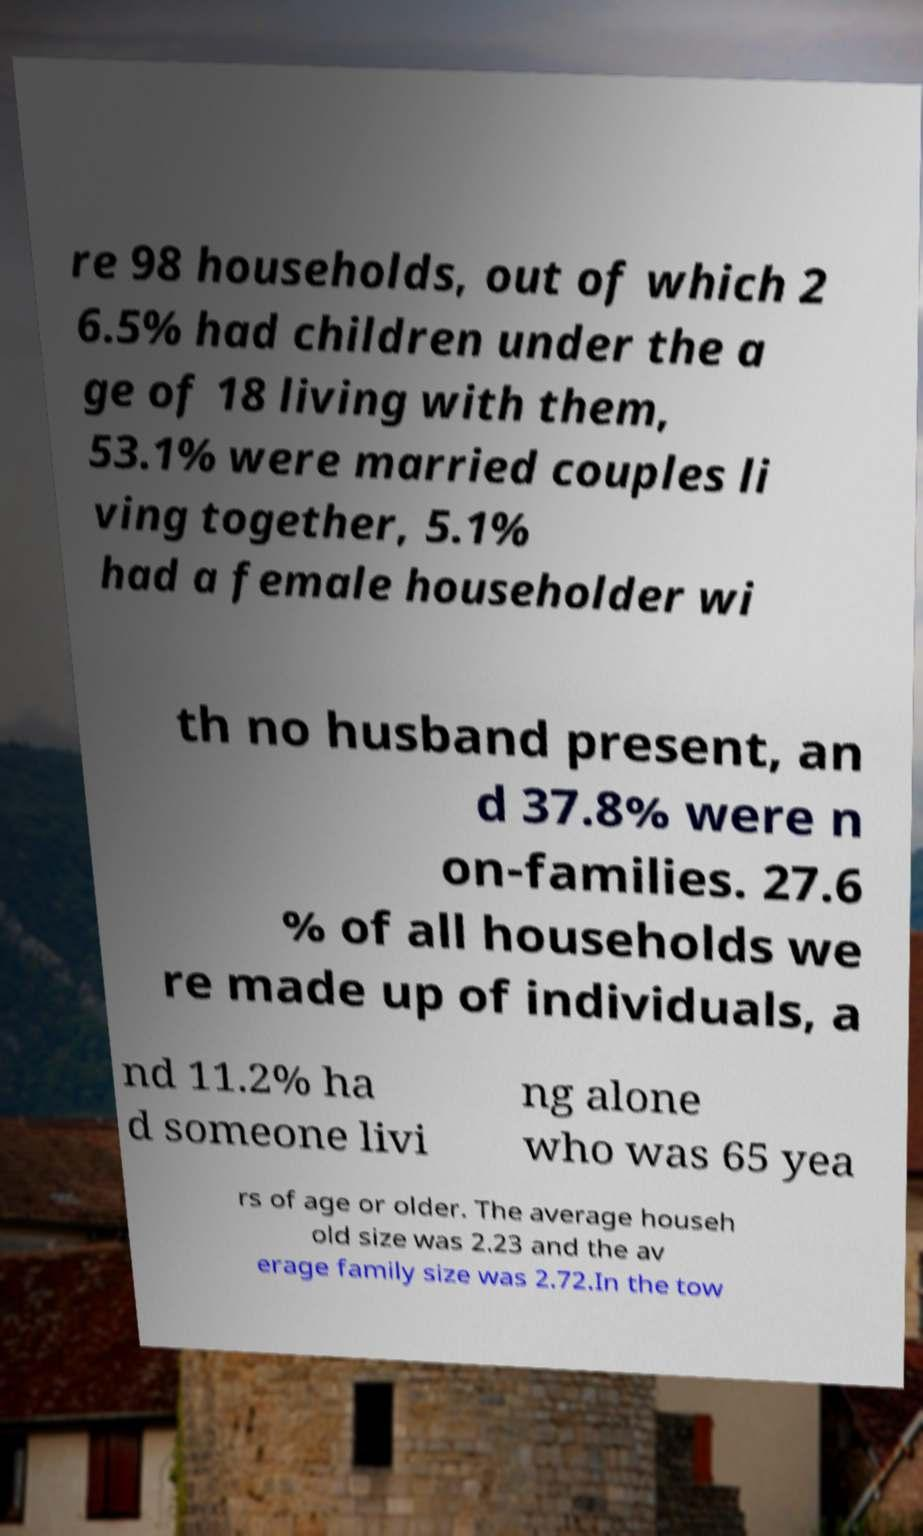What messages or text are displayed in this image? I need them in a readable, typed format. re 98 households, out of which 2 6.5% had children under the a ge of 18 living with them, 53.1% were married couples li ving together, 5.1% had a female householder wi th no husband present, an d 37.8% were n on-families. 27.6 % of all households we re made up of individuals, a nd 11.2% ha d someone livi ng alone who was 65 yea rs of age or older. The average househ old size was 2.23 and the av erage family size was 2.72.In the tow 